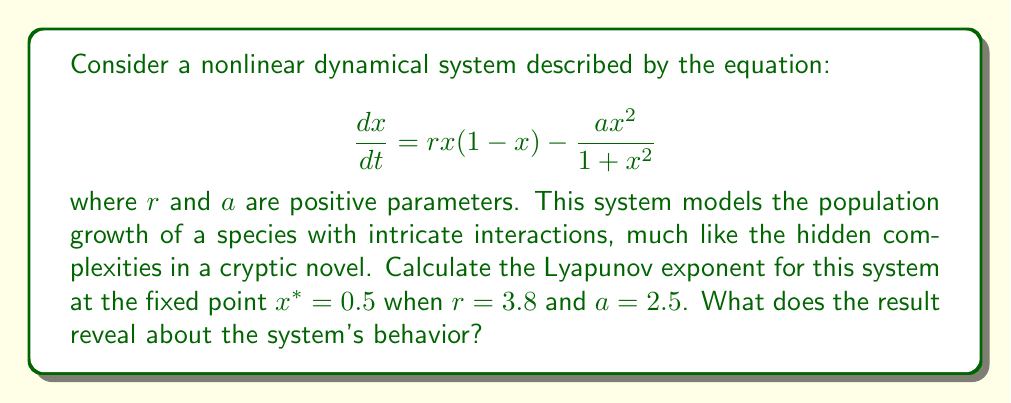Provide a solution to this math problem. To analyze the chaotic behavior of this nonlinear dynamical system using Lyapunov exponents, we'll follow these steps:

1) First, we need to find the derivative of the function with respect to x:

   $$\frac{df}{dx} = r(1-2x) - \frac{2ax(1+x^2) - 2ax^3}{(1+x^2)^2}$$

2) Now, we evaluate this derivative at the fixed point $x^* = 0.5$:

   $$\left.\frac{df}{dx}\right|_{x=0.5} = r(1-2(0.5)) - \frac{2a(0.5)(1+0.5^2) - 2a(0.5)^3}{(1+0.5^2)^2}$$

3) Substitute the given values $r = 3.8$ and $a = 2.5$:

   $$\left.\frac{df}{dx}\right|_{x=0.5} = 3.8(0) - \frac{2(2.5)(0.5)(1.25) - 2(2.5)(0.125)}{(1.25)^2}$$

4) Simplify:

   $$\left.\frac{df}{dx}\right|_{x=0.5} = 0 - \frac{3.125 - 0.625}{1.5625} = -1.6$$

5) The Lyapunov exponent λ for a discrete-time system is given by:

   $$\lambda = \ln\left|\frac{df}{dx}\right|$$

6) Therefore:

   $$\lambda = \ln|{-1.6}| = 0.47$$

The positive Lyapunov exponent (λ > 0) indicates that the system exhibits chaotic behavior at this fixed point. This means that nearby trajectories diverge exponentially, making long-term predictions impossible, much like the elusive meaning behind the writer's enigmatic novels.
Answer: λ ≈ 0.47 (chaotic behavior) 